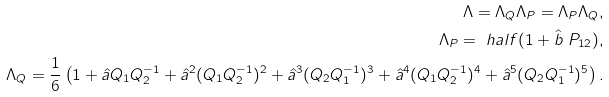<formula> <loc_0><loc_0><loc_500><loc_500>\Lambda = \Lambda _ { Q } \Lambda _ { P } = \Lambda _ { P } \Lambda _ { Q } , \\ \Lambda _ { P } = \ h a l f ( 1 + \hat { b } \ P _ { 1 2 } ) , \\ \Lambda _ { Q } = \frac { 1 } { 6 } \left ( 1 + \hat { a } Q _ { 1 } Q _ { 2 } ^ { - 1 } + \hat { a } ^ { 2 } ( Q _ { 1 } Q _ { 2 } ^ { - 1 } ) ^ { 2 } + \hat { a } ^ { 3 } ( Q _ { 2 } Q _ { 1 } ^ { - 1 } ) ^ { 3 } + \hat { a } ^ { 4 } ( Q _ { 1 } Q _ { 2 } ^ { - 1 } ) ^ { 4 } + \hat { a } ^ { 5 } ( Q _ { 2 } Q _ { 1 } ^ { - 1 } ) ^ { 5 } \right ) .</formula> 